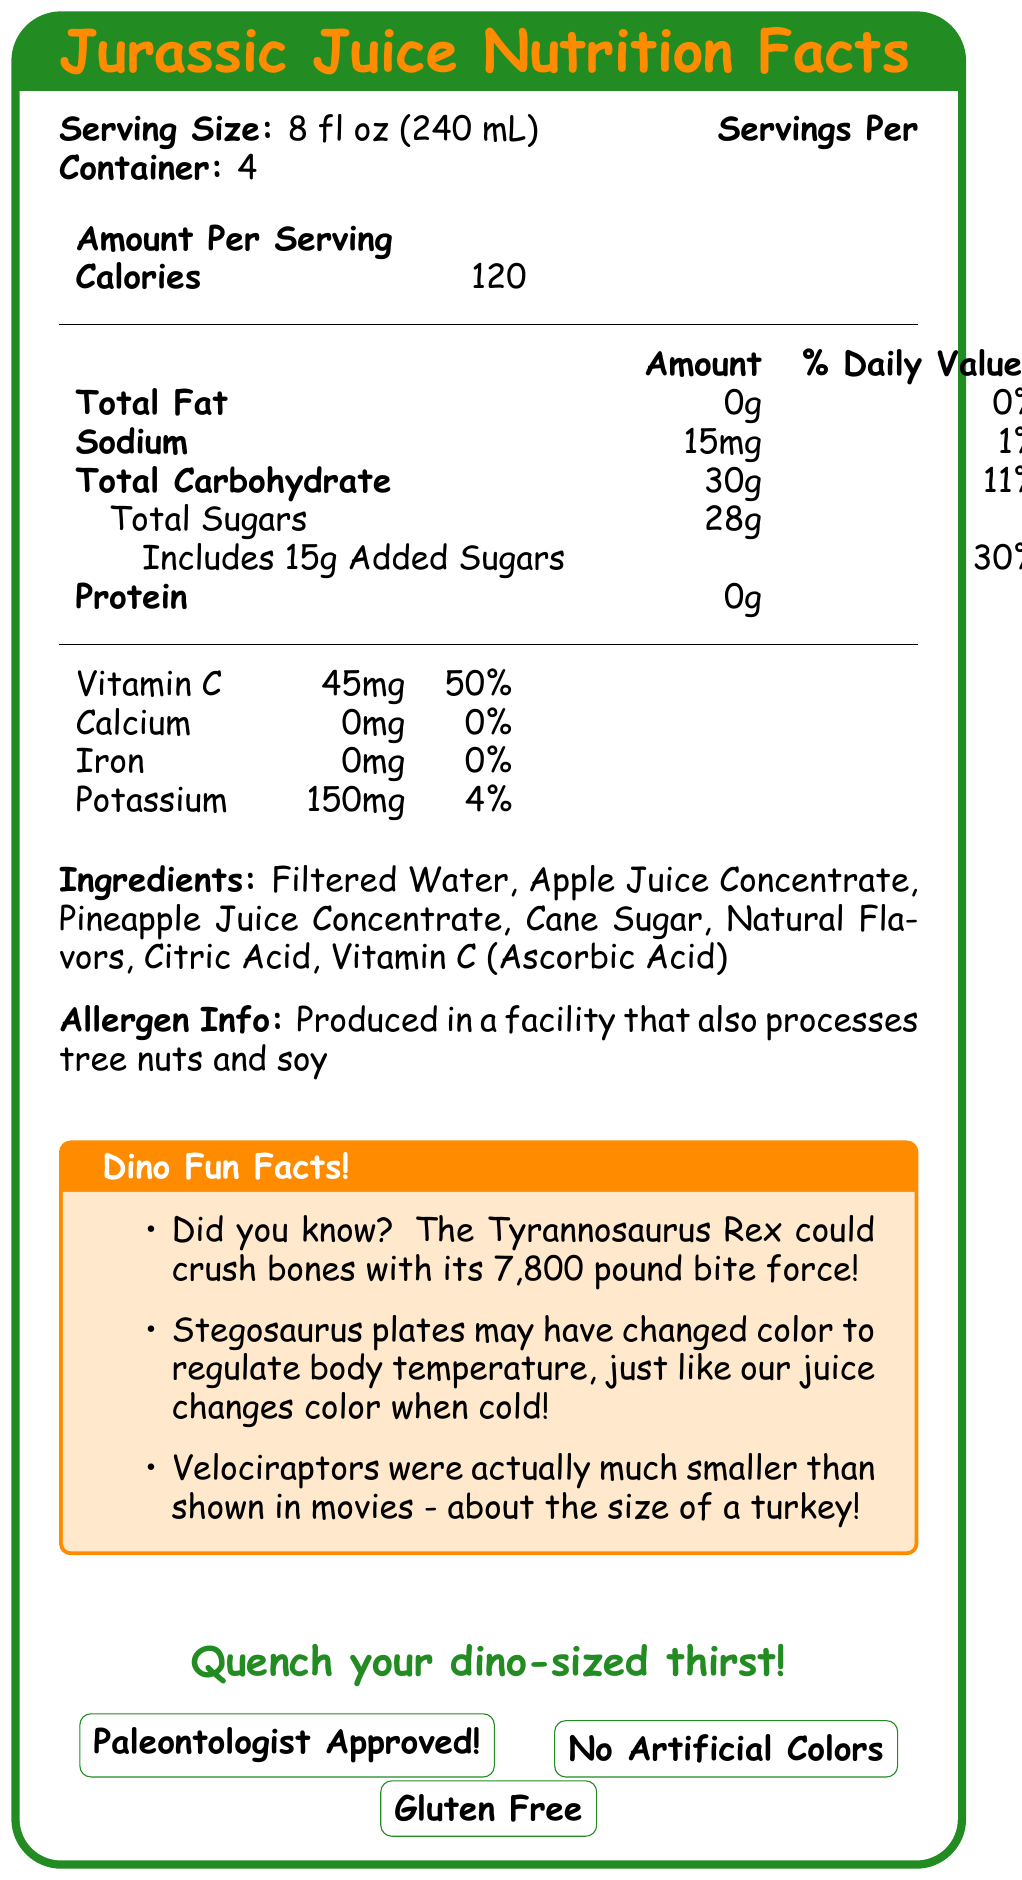what is the serving size? The serving size is specified right below the title "Jurassic Juice Nutrition Facts": 8 fl oz (240 mL).
Answer: 8 fl oz (240 mL) how many calories are in a single serving? The amount of calories per serving is shown under "Calories": 120.
Answer: 120 what is the percentage of daily value for Vitamin C? The document lists Vitamin C under their amounts per serving, indicating 45mg which is 50% of the daily value.
Answer: 50% how many servings are in one container? The number of servings per container is specified next to the serving size: 4.
Answer: 4 what allergen information is provided? The allergen information is clearly stated in the Allergen Info section: "Produced in a facility that also processes tree nuts and soy."
Answer: Produced in a facility that also processes tree nuts and soy how much sodium is in one serving? Under the nutritional information, sodium content per serving is listed as 15mg.
Answer: 15mg what is the slogan of the product? The slogan "Quench your dino-sized thirst!" is shown at the bottom of the document in large, green text.
Answer: Quench your dino-sized thirst! what fun fact about Velociraptors is mentioned? In the Dino Fun Facts section, it states: "Velociraptors were actually much smaller than shown in movies - about the size of a turkey!"
Answer: Velociraptors were actually much smaller than shown in movies - about the size of a turkey! which of the following nutrients is present in the highest quantity? A. Sodium B. Total Sugars C. Potassium D. Protein The amount per serving for Total Sugars is 28g, which is higher compared to Sodium (15mg), Potassium (150mg), and Protein (0g).
Answer: B which of the following ingredients is NOT listed in Jurassic Juice? A. Citric Acid B. Vitamin C (Ascorbic Acid) C. High Fructose Corn Syrup High Fructose Corn Syrup is not listed in the ingredients. The listed ingredients include Citric Acid and Vitamin C (Ascorbic Acid).
Answer: C is the product gluten-free? The document explicitly states that the product is gluten-free near the bottom of the page.
Answer: Yes does the juice contain any artificial colors or flavors? The document states that the product has no artificial colors or flavors.
Answer: No what is the main idea of the document? The document provides the nutritional information for Jurassic Juice, including calories, fat, sodium, carbohydrates, sugars, protein, vitamins, and minerals per serving. It also lists the ingredients, allergen information, and fun facts about dinosaurs, along with the product features such as being gluten-free, having no artificial colors or flavors, and being paleontologist-approved.
Answer: Nutrition Facts and Highlights of Jurassic Juice how many grams of added sugar does each serving of Jurassic Juice contain? The nutritional information indicates that each serving includes 15g of added sugars.
Answer: 15g which dinosaur illustration is featured on the document? The document mentions colorful dinosaur illustrations like a Triceratops sipping juice and a Pterodactyl carrying a bottle of Jurassic Juice, but it does not visually depict them within the provided LaTeX document description.
Answer: Cannot be determined 